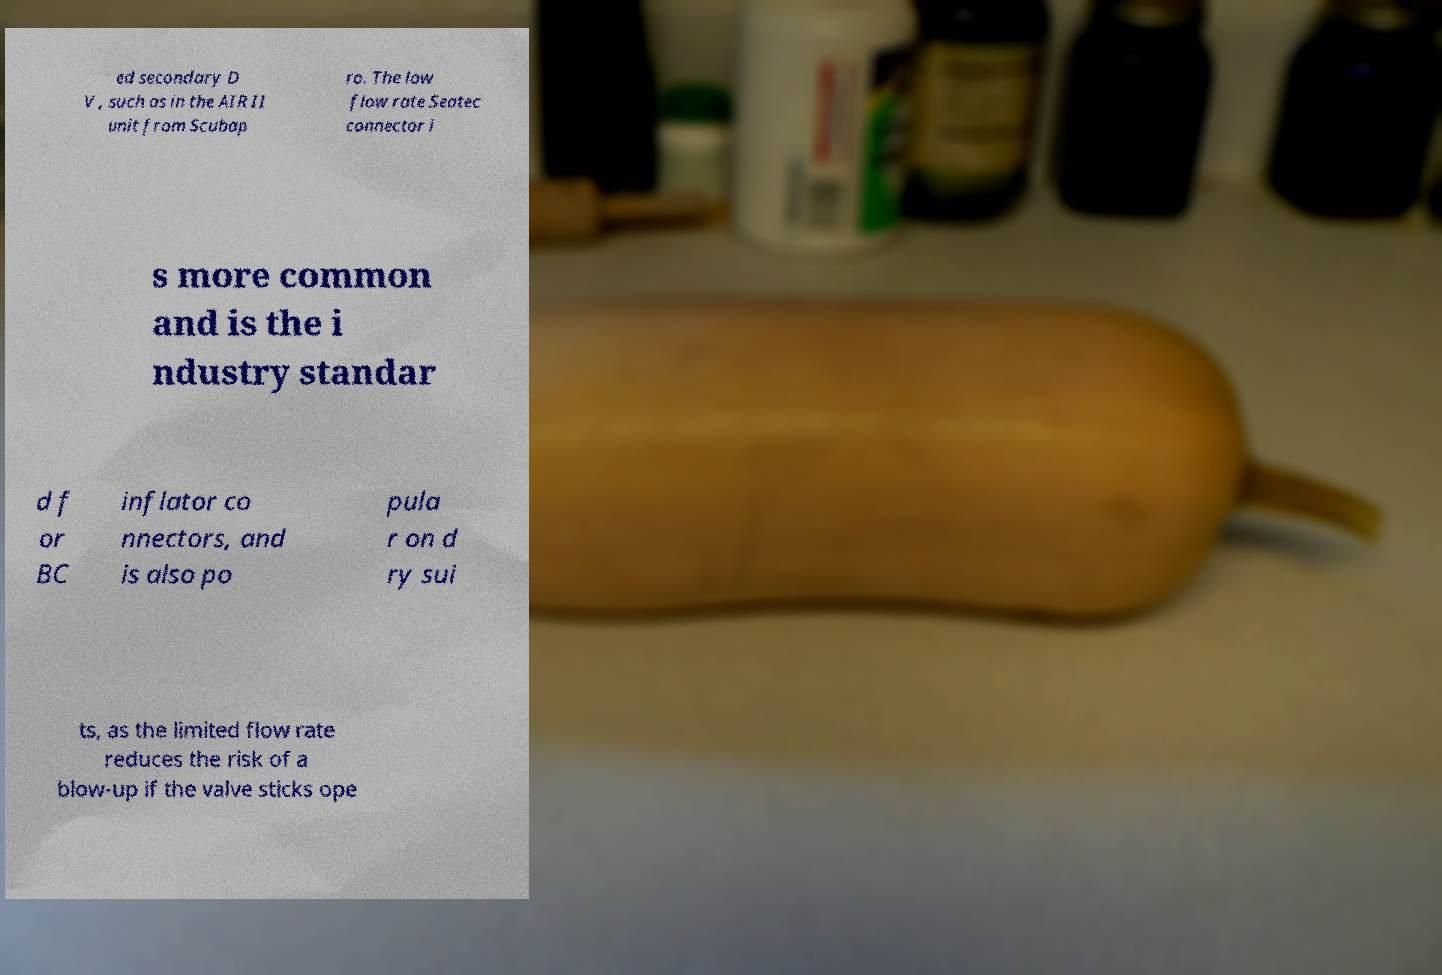Can you read and provide the text displayed in the image?This photo seems to have some interesting text. Can you extract and type it out for me? ed secondary D V , such as in the AIR II unit from Scubap ro. The low flow rate Seatec connector i s more common and is the i ndustry standar d f or BC inflator co nnectors, and is also po pula r on d ry sui ts, as the limited flow rate reduces the risk of a blow-up if the valve sticks ope 